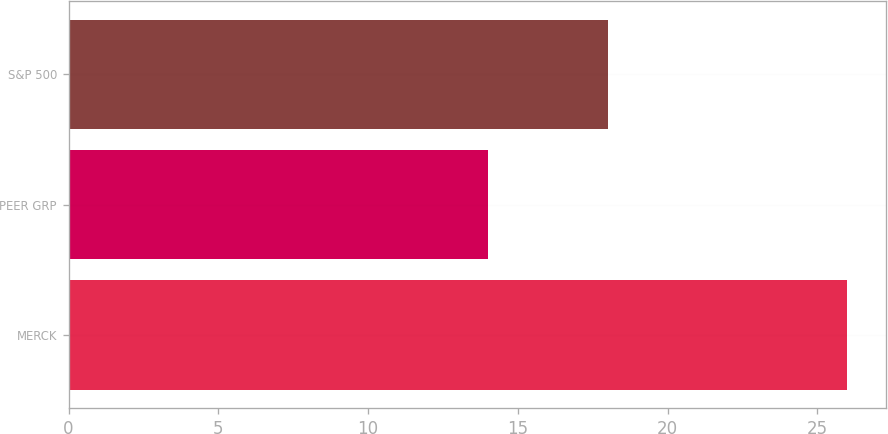Convert chart. <chart><loc_0><loc_0><loc_500><loc_500><bar_chart><fcel>MERCK<fcel>PEER GRP<fcel>S&P 500<nl><fcel>26<fcel>14<fcel>18<nl></chart> 